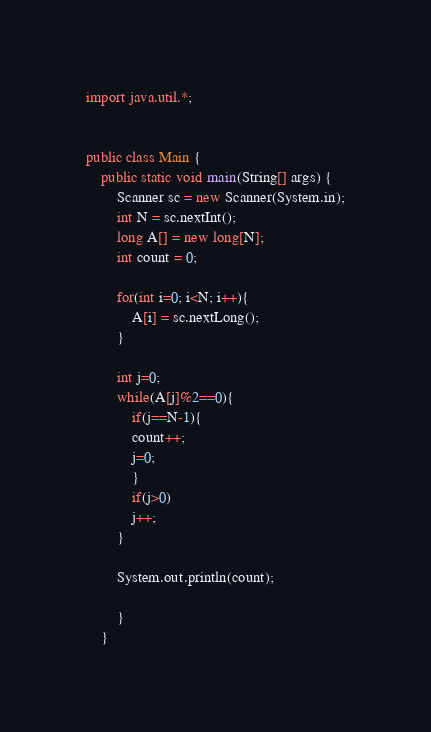Convert code to text. <code><loc_0><loc_0><loc_500><loc_500><_Java_>import java.util.*;
 

public class Main {
    public static void main(String[] args) {   
        Scanner sc = new Scanner(System.in);
        int N = sc.nextInt();
        long A[] = new long[N]; 
        int count = 0;

        for(int i=0; i<N; i++){
            A[i] = sc.nextLong();
        }

        int j=0;
        while(A[j]%2==0){
            if(j==N-1){
            count++;
            j=0;
            }
            if(j>0)
            j++;
        }

        System.out.println(count);

        }
    }    



</code> 